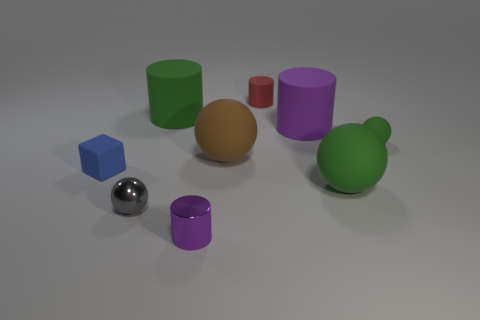There is a rubber thing in front of the small blue matte block; what is its shape?
Keep it short and to the point. Sphere. Do the purple cylinder in front of the large green ball and the tiny sphere that is behind the gray metallic sphere have the same material?
Ensure brevity in your answer.  No. There is a big purple rubber object; what shape is it?
Keep it short and to the point. Cylinder. Is the number of tiny matte spheres that are behind the tiny rubber ball the same as the number of green metallic cylinders?
Offer a very short reply. Yes. The object that is the same color as the tiny metallic cylinder is what size?
Offer a terse response. Large. Is there a small cylinder that has the same material as the tiny block?
Provide a succinct answer. Yes. There is a thing that is in front of the gray metal ball; is it the same shape as the green object left of the tiny purple shiny thing?
Offer a very short reply. Yes. Are there any tiny green metallic cylinders?
Your answer should be compact. No. The ball that is the same size as the brown matte object is what color?
Provide a succinct answer. Green. What number of small green things have the same shape as the tiny red matte object?
Offer a very short reply. 0. 